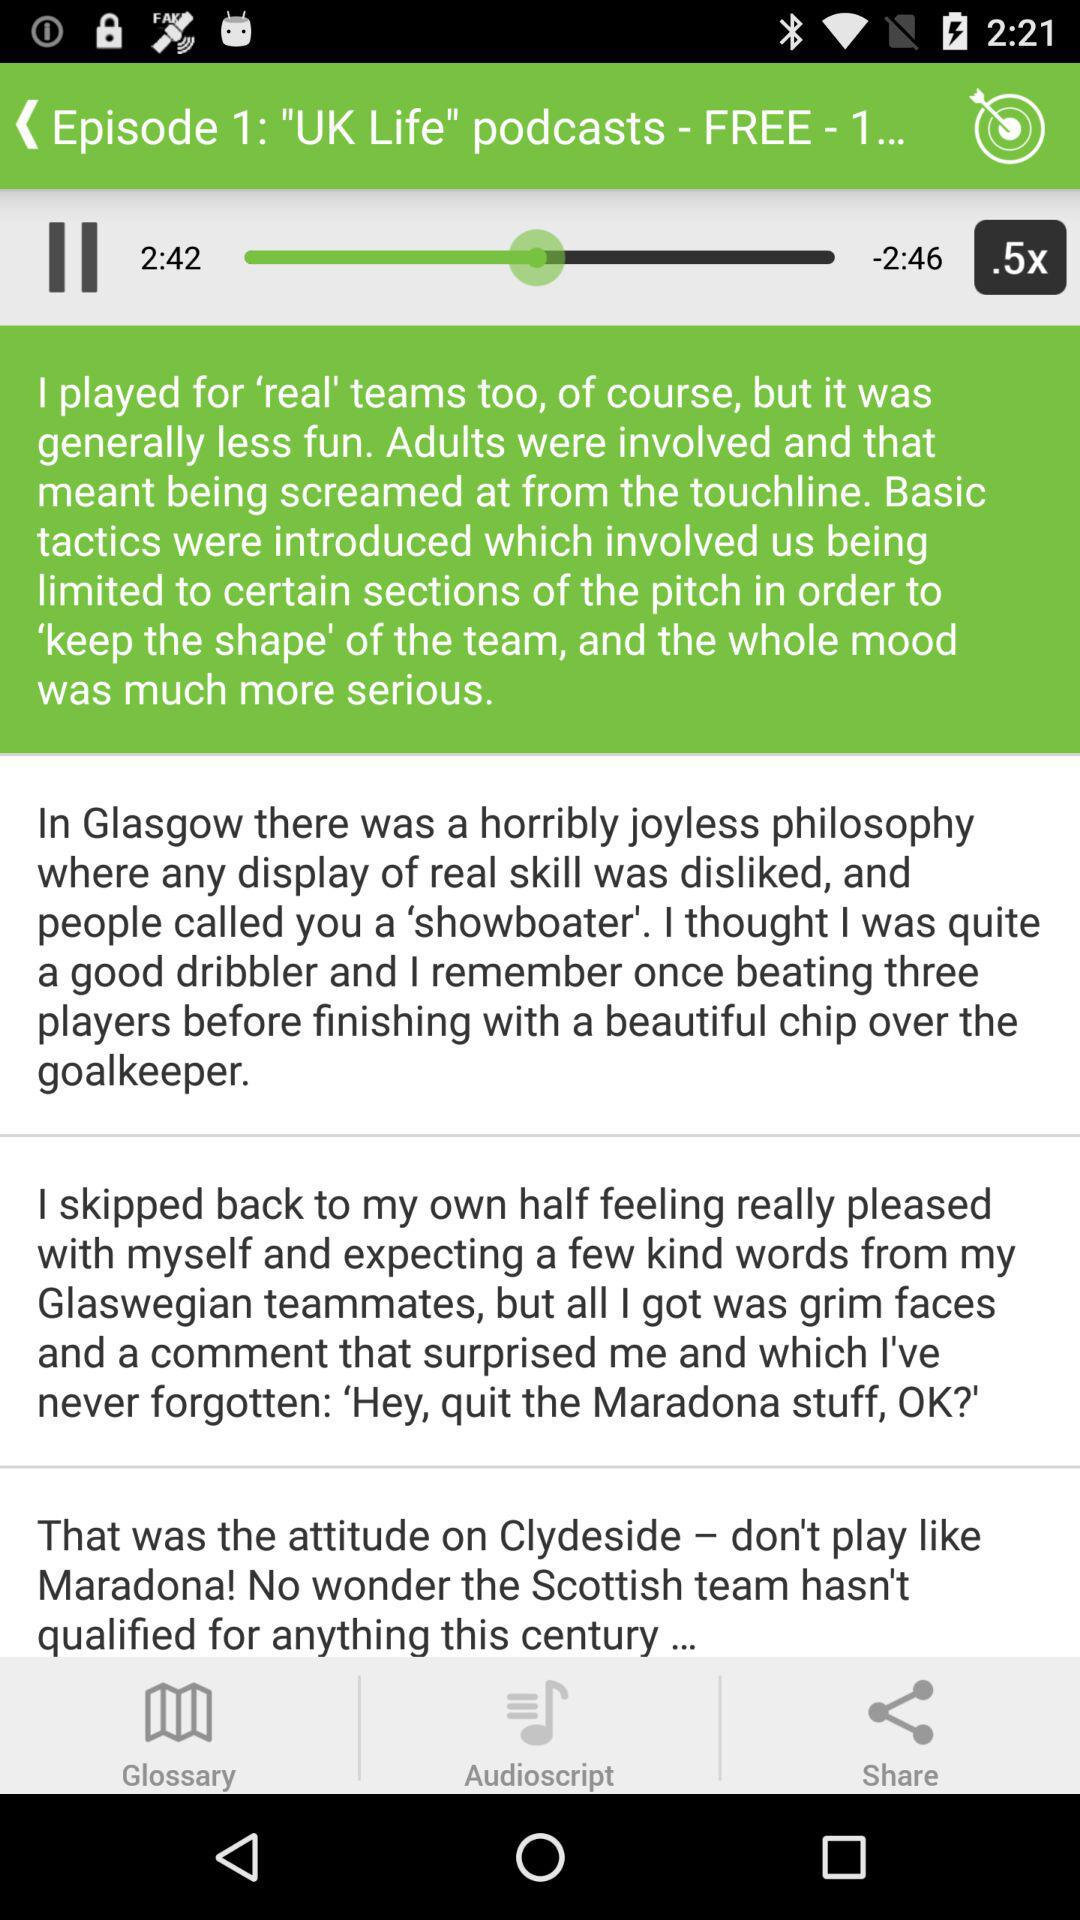Which episode is this? This is the first episode. 